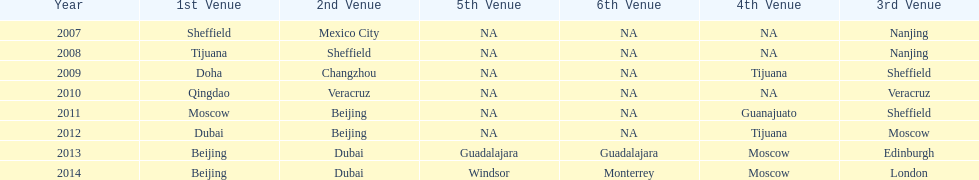Can you give me this table as a dict? {'header': ['Year', '1st Venue', '2nd Venue', '5th Venue', '6th Venue', '4th Venue', '3rd Venue'], 'rows': [['2007', 'Sheffield', 'Mexico City', 'NA', 'NA', 'NA', 'Nanjing'], ['2008', 'Tijuana', 'Sheffield', 'NA', 'NA', 'NA', 'Nanjing'], ['2009', 'Doha', 'Changzhou', 'NA', 'NA', 'Tijuana', 'Sheffield'], ['2010', 'Qingdao', 'Veracruz', 'NA', 'NA', 'NA', 'Veracruz'], ['2011', 'Moscow', 'Beijing', 'NA', 'NA', 'Guanajuato', 'Sheffield'], ['2012', 'Dubai', 'Beijing', 'NA', 'NA', 'Tijuana', 'Moscow'], ['2013', 'Beijing', 'Dubai', 'Guadalajara', 'Guadalajara', 'Moscow', 'Edinburgh'], ['2014', 'Beijing', 'Dubai', 'Windsor', 'Monterrey', 'Moscow', 'London']]} Which year is previous to 2011 2010. 